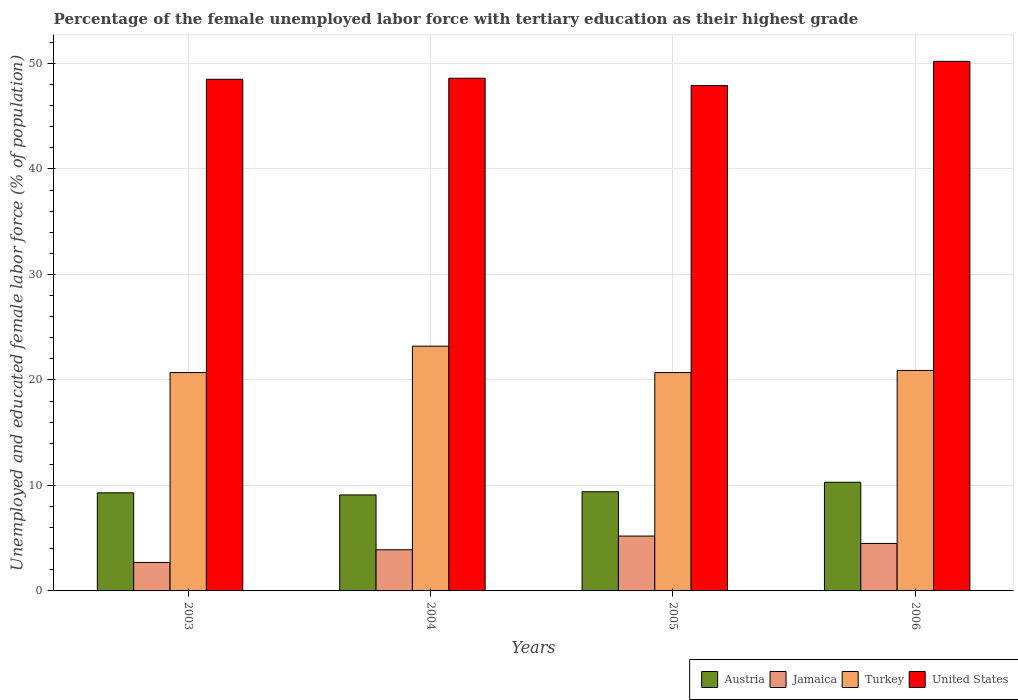How many different coloured bars are there?
Provide a succinct answer. 4. Are the number of bars on each tick of the X-axis equal?
Offer a terse response. Yes. How many bars are there on the 2nd tick from the right?
Make the answer very short. 4. What is the percentage of the unemployed female labor force with tertiary education in Turkey in 2006?
Your response must be concise. 20.9. Across all years, what is the maximum percentage of the unemployed female labor force with tertiary education in United States?
Offer a very short reply. 50.2. Across all years, what is the minimum percentage of the unemployed female labor force with tertiary education in Jamaica?
Provide a succinct answer. 2.7. In which year was the percentage of the unemployed female labor force with tertiary education in Jamaica maximum?
Ensure brevity in your answer.  2005. What is the total percentage of the unemployed female labor force with tertiary education in Austria in the graph?
Your answer should be very brief. 38.1. What is the difference between the percentage of the unemployed female labor force with tertiary education in United States in 2003 and the percentage of the unemployed female labor force with tertiary education in Austria in 2005?
Your answer should be very brief. 39.1. What is the average percentage of the unemployed female labor force with tertiary education in Jamaica per year?
Offer a very short reply. 4.07. In the year 2006, what is the difference between the percentage of the unemployed female labor force with tertiary education in Turkey and percentage of the unemployed female labor force with tertiary education in United States?
Offer a terse response. -29.3. In how many years, is the percentage of the unemployed female labor force with tertiary education in Turkey greater than 28 %?
Provide a succinct answer. 0. What is the ratio of the percentage of the unemployed female labor force with tertiary education in United States in 2003 to that in 2005?
Provide a succinct answer. 1.01. Is the difference between the percentage of the unemployed female labor force with tertiary education in Turkey in 2005 and 2006 greater than the difference between the percentage of the unemployed female labor force with tertiary education in United States in 2005 and 2006?
Offer a very short reply. Yes. What is the difference between the highest and the second highest percentage of the unemployed female labor force with tertiary education in Jamaica?
Keep it short and to the point. 0.7. What is the difference between the highest and the lowest percentage of the unemployed female labor force with tertiary education in Jamaica?
Make the answer very short. 2.5. Is the sum of the percentage of the unemployed female labor force with tertiary education in Austria in 2004 and 2006 greater than the maximum percentage of the unemployed female labor force with tertiary education in Jamaica across all years?
Provide a succinct answer. Yes. Is it the case that in every year, the sum of the percentage of the unemployed female labor force with tertiary education in Jamaica and percentage of the unemployed female labor force with tertiary education in Austria is greater than the sum of percentage of the unemployed female labor force with tertiary education in United States and percentage of the unemployed female labor force with tertiary education in Turkey?
Your answer should be compact. No. What does the 2nd bar from the left in 2003 represents?
Make the answer very short. Jamaica. What does the 1st bar from the right in 2003 represents?
Your answer should be compact. United States. Is it the case that in every year, the sum of the percentage of the unemployed female labor force with tertiary education in United States and percentage of the unemployed female labor force with tertiary education in Turkey is greater than the percentage of the unemployed female labor force with tertiary education in Jamaica?
Offer a terse response. Yes. How many bars are there?
Make the answer very short. 16. Are all the bars in the graph horizontal?
Offer a very short reply. No. Are the values on the major ticks of Y-axis written in scientific E-notation?
Keep it short and to the point. No. Does the graph contain any zero values?
Ensure brevity in your answer.  No. Does the graph contain grids?
Keep it short and to the point. Yes. Where does the legend appear in the graph?
Provide a short and direct response. Bottom right. How are the legend labels stacked?
Offer a terse response. Horizontal. What is the title of the graph?
Give a very brief answer. Percentage of the female unemployed labor force with tertiary education as their highest grade. What is the label or title of the X-axis?
Your answer should be very brief. Years. What is the label or title of the Y-axis?
Your answer should be compact. Unemployed and educated female labor force (% of population). What is the Unemployed and educated female labor force (% of population) of Austria in 2003?
Keep it short and to the point. 9.3. What is the Unemployed and educated female labor force (% of population) in Jamaica in 2003?
Give a very brief answer. 2.7. What is the Unemployed and educated female labor force (% of population) of Turkey in 2003?
Provide a succinct answer. 20.7. What is the Unemployed and educated female labor force (% of population) of United States in 2003?
Your response must be concise. 48.5. What is the Unemployed and educated female labor force (% of population) of Austria in 2004?
Give a very brief answer. 9.1. What is the Unemployed and educated female labor force (% of population) in Jamaica in 2004?
Ensure brevity in your answer.  3.9. What is the Unemployed and educated female labor force (% of population) in Turkey in 2004?
Provide a short and direct response. 23.2. What is the Unemployed and educated female labor force (% of population) of United States in 2004?
Provide a short and direct response. 48.6. What is the Unemployed and educated female labor force (% of population) of Austria in 2005?
Keep it short and to the point. 9.4. What is the Unemployed and educated female labor force (% of population) of Jamaica in 2005?
Provide a succinct answer. 5.2. What is the Unemployed and educated female labor force (% of population) in Turkey in 2005?
Keep it short and to the point. 20.7. What is the Unemployed and educated female labor force (% of population) in United States in 2005?
Your answer should be very brief. 47.9. What is the Unemployed and educated female labor force (% of population) in Austria in 2006?
Provide a succinct answer. 10.3. What is the Unemployed and educated female labor force (% of population) in Turkey in 2006?
Make the answer very short. 20.9. What is the Unemployed and educated female labor force (% of population) of United States in 2006?
Your response must be concise. 50.2. Across all years, what is the maximum Unemployed and educated female labor force (% of population) in Austria?
Offer a very short reply. 10.3. Across all years, what is the maximum Unemployed and educated female labor force (% of population) in Jamaica?
Offer a terse response. 5.2. Across all years, what is the maximum Unemployed and educated female labor force (% of population) of Turkey?
Your answer should be compact. 23.2. Across all years, what is the maximum Unemployed and educated female labor force (% of population) of United States?
Provide a succinct answer. 50.2. Across all years, what is the minimum Unemployed and educated female labor force (% of population) of Austria?
Make the answer very short. 9.1. Across all years, what is the minimum Unemployed and educated female labor force (% of population) of Jamaica?
Give a very brief answer. 2.7. Across all years, what is the minimum Unemployed and educated female labor force (% of population) in Turkey?
Ensure brevity in your answer.  20.7. Across all years, what is the minimum Unemployed and educated female labor force (% of population) in United States?
Your response must be concise. 47.9. What is the total Unemployed and educated female labor force (% of population) in Austria in the graph?
Provide a succinct answer. 38.1. What is the total Unemployed and educated female labor force (% of population) of Jamaica in the graph?
Ensure brevity in your answer.  16.3. What is the total Unemployed and educated female labor force (% of population) in Turkey in the graph?
Keep it short and to the point. 85.5. What is the total Unemployed and educated female labor force (% of population) in United States in the graph?
Provide a succinct answer. 195.2. What is the difference between the Unemployed and educated female labor force (% of population) of Austria in 2003 and that in 2005?
Offer a terse response. -0.1. What is the difference between the Unemployed and educated female labor force (% of population) in Jamaica in 2003 and that in 2005?
Provide a succinct answer. -2.5. What is the difference between the Unemployed and educated female labor force (% of population) in United States in 2003 and that in 2005?
Your response must be concise. 0.6. What is the difference between the Unemployed and educated female labor force (% of population) in Austria in 2004 and that in 2005?
Give a very brief answer. -0.3. What is the difference between the Unemployed and educated female labor force (% of population) of Turkey in 2004 and that in 2005?
Offer a very short reply. 2.5. What is the difference between the Unemployed and educated female labor force (% of population) of United States in 2004 and that in 2005?
Offer a very short reply. 0.7. What is the difference between the Unemployed and educated female labor force (% of population) of Turkey in 2004 and that in 2006?
Your answer should be very brief. 2.3. What is the difference between the Unemployed and educated female labor force (% of population) of United States in 2005 and that in 2006?
Provide a succinct answer. -2.3. What is the difference between the Unemployed and educated female labor force (% of population) in Austria in 2003 and the Unemployed and educated female labor force (% of population) in United States in 2004?
Offer a terse response. -39.3. What is the difference between the Unemployed and educated female labor force (% of population) of Jamaica in 2003 and the Unemployed and educated female labor force (% of population) of Turkey in 2004?
Your answer should be compact. -20.5. What is the difference between the Unemployed and educated female labor force (% of population) of Jamaica in 2003 and the Unemployed and educated female labor force (% of population) of United States in 2004?
Give a very brief answer. -45.9. What is the difference between the Unemployed and educated female labor force (% of population) of Turkey in 2003 and the Unemployed and educated female labor force (% of population) of United States in 2004?
Provide a succinct answer. -27.9. What is the difference between the Unemployed and educated female labor force (% of population) of Austria in 2003 and the Unemployed and educated female labor force (% of population) of Jamaica in 2005?
Give a very brief answer. 4.1. What is the difference between the Unemployed and educated female labor force (% of population) in Austria in 2003 and the Unemployed and educated female labor force (% of population) in United States in 2005?
Make the answer very short. -38.6. What is the difference between the Unemployed and educated female labor force (% of population) in Jamaica in 2003 and the Unemployed and educated female labor force (% of population) in United States in 2005?
Provide a succinct answer. -45.2. What is the difference between the Unemployed and educated female labor force (% of population) in Turkey in 2003 and the Unemployed and educated female labor force (% of population) in United States in 2005?
Keep it short and to the point. -27.2. What is the difference between the Unemployed and educated female labor force (% of population) in Austria in 2003 and the Unemployed and educated female labor force (% of population) in Turkey in 2006?
Offer a terse response. -11.6. What is the difference between the Unemployed and educated female labor force (% of population) in Austria in 2003 and the Unemployed and educated female labor force (% of population) in United States in 2006?
Keep it short and to the point. -40.9. What is the difference between the Unemployed and educated female labor force (% of population) in Jamaica in 2003 and the Unemployed and educated female labor force (% of population) in Turkey in 2006?
Give a very brief answer. -18.2. What is the difference between the Unemployed and educated female labor force (% of population) of Jamaica in 2003 and the Unemployed and educated female labor force (% of population) of United States in 2006?
Your answer should be compact. -47.5. What is the difference between the Unemployed and educated female labor force (% of population) of Turkey in 2003 and the Unemployed and educated female labor force (% of population) of United States in 2006?
Your answer should be very brief. -29.5. What is the difference between the Unemployed and educated female labor force (% of population) of Austria in 2004 and the Unemployed and educated female labor force (% of population) of Jamaica in 2005?
Your answer should be very brief. 3.9. What is the difference between the Unemployed and educated female labor force (% of population) of Austria in 2004 and the Unemployed and educated female labor force (% of population) of United States in 2005?
Your answer should be very brief. -38.8. What is the difference between the Unemployed and educated female labor force (% of population) of Jamaica in 2004 and the Unemployed and educated female labor force (% of population) of Turkey in 2005?
Provide a short and direct response. -16.8. What is the difference between the Unemployed and educated female labor force (% of population) of Jamaica in 2004 and the Unemployed and educated female labor force (% of population) of United States in 2005?
Provide a short and direct response. -44. What is the difference between the Unemployed and educated female labor force (% of population) in Turkey in 2004 and the Unemployed and educated female labor force (% of population) in United States in 2005?
Give a very brief answer. -24.7. What is the difference between the Unemployed and educated female labor force (% of population) of Austria in 2004 and the Unemployed and educated female labor force (% of population) of Jamaica in 2006?
Provide a succinct answer. 4.6. What is the difference between the Unemployed and educated female labor force (% of population) of Austria in 2004 and the Unemployed and educated female labor force (% of population) of United States in 2006?
Offer a terse response. -41.1. What is the difference between the Unemployed and educated female labor force (% of population) of Jamaica in 2004 and the Unemployed and educated female labor force (% of population) of United States in 2006?
Keep it short and to the point. -46.3. What is the difference between the Unemployed and educated female labor force (% of population) in Turkey in 2004 and the Unemployed and educated female labor force (% of population) in United States in 2006?
Keep it short and to the point. -27. What is the difference between the Unemployed and educated female labor force (% of population) of Austria in 2005 and the Unemployed and educated female labor force (% of population) of Turkey in 2006?
Your response must be concise. -11.5. What is the difference between the Unemployed and educated female labor force (% of population) in Austria in 2005 and the Unemployed and educated female labor force (% of population) in United States in 2006?
Provide a short and direct response. -40.8. What is the difference between the Unemployed and educated female labor force (% of population) in Jamaica in 2005 and the Unemployed and educated female labor force (% of population) in Turkey in 2006?
Ensure brevity in your answer.  -15.7. What is the difference between the Unemployed and educated female labor force (% of population) of Jamaica in 2005 and the Unemployed and educated female labor force (% of population) of United States in 2006?
Your answer should be compact. -45. What is the difference between the Unemployed and educated female labor force (% of population) in Turkey in 2005 and the Unemployed and educated female labor force (% of population) in United States in 2006?
Give a very brief answer. -29.5. What is the average Unemployed and educated female labor force (% of population) in Austria per year?
Give a very brief answer. 9.53. What is the average Unemployed and educated female labor force (% of population) in Jamaica per year?
Provide a succinct answer. 4.08. What is the average Unemployed and educated female labor force (% of population) in Turkey per year?
Ensure brevity in your answer.  21.38. What is the average Unemployed and educated female labor force (% of population) of United States per year?
Your answer should be very brief. 48.8. In the year 2003, what is the difference between the Unemployed and educated female labor force (% of population) of Austria and Unemployed and educated female labor force (% of population) of Jamaica?
Offer a very short reply. 6.6. In the year 2003, what is the difference between the Unemployed and educated female labor force (% of population) of Austria and Unemployed and educated female labor force (% of population) of Turkey?
Ensure brevity in your answer.  -11.4. In the year 2003, what is the difference between the Unemployed and educated female labor force (% of population) in Austria and Unemployed and educated female labor force (% of population) in United States?
Ensure brevity in your answer.  -39.2. In the year 2003, what is the difference between the Unemployed and educated female labor force (% of population) of Jamaica and Unemployed and educated female labor force (% of population) of United States?
Offer a terse response. -45.8. In the year 2003, what is the difference between the Unemployed and educated female labor force (% of population) of Turkey and Unemployed and educated female labor force (% of population) of United States?
Your response must be concise. -27.8. In the year 2004, what is the difference between the Unemployed and educated female labor force (% of population) of Austria and Unemployed and educated female labor force (% of population) of Turkey?
Provide a succinct answer. -14.1. In the year 2004, what is the difference between the Unemployed and educated female labor force (% of population) in Austria and Unemployed and educated female labor force (% of population) in United States?
Provide a short and direct response. -39.5. In the year 2004, what is the difference between the Unemployed and educated female labor force (% of population) of Jamaica and Unemployed and educated female labor force (% of population) of Turkey?
Provide a short and direct response. -19.3. In the year 2004, what is the difference between the Unemployed and educated female labor force (% of population) of Jamaica and Unemployed and educated female labor force (% of population) of United States?
Provide a succinct answer. -44.7. In the year 2004, what is the difference between the Unemployed and educated female labor force (% of population) in Turkey and Unemployed and educated female labor force (% of population) in United States?
Your answer should be compact. -25.4. In the year 2005, what is the difference between the Unemployed and educated female labor force (% of population) in Austria and Unemployed and educated female labor force (% of population) in Jamaica?
Keep it short and to the point. 4.2. In the year 2005, what is the difference between the Unemployed and educated female labor force (% of population) of Austria and Unemployed and educated female labor force (% of population) of Turkey?
Offer a terse response. -11.3. In the year 2005, what is the difference between the Unemployed and educated female labor force (% of population) of Austria and Unemployed and educated female labor force (% of population) of United States?
Provide a short and direct response. -38.5. In the year 2005, what is the difference between the Unemployed and educated female labor force (% of population) of Jamaica and Unemployed and educated female labor force (% of population) of Turkey?
Give a very brief answer. -15.5. In the year 2005, what is the difference between the Unemployed and educated female labor force (% of population) of Jamaica and Unemployed and educated female labor force (% of population) of United States?
Provide a succinct answer. -42.7. In the year 2005, what is the difference between the Unemployed and educated female labor force (% of population) of Turkey and Unemployed and educated female labor force (% of population) of United States?
Provide a succinct answer. -27.2. In the year 2006, what is the difference between the Unemployed and educated female labor force (% of population) of Austria and Unemployed and educated female labor force (% of population) of United States?
Offer a very short reply. -39.9. In the year 2006, what is the difference between the Unemployed and educated female labor force (% of population) of Jamaica and Unemployed and educated female labor force (% of population) of Turkey?
Your answer should be very brief. -16.4. In the year 2006, what is the difference between the Unemployed and educated female labor force (% of population) of Jamaica and Unemployed and educated female labor force (% of population) of United States?
Your response must be concise. -45.7. In the year 2006, what is the difference between the Unemployed and educated female labor force (% of population) of Turkey and Unemployed and educated female labor force (% of population) of United States?
Offer a very short reply. -29.3. What is the ratio of the Unemployed and educated female labor force (% of population) of Austria in 2003 to that in 2004?
Your answer should be very brief. 1.02. What is the ratio of the Unemployed and educated female labor force (% of population) in Jamaica in 2003 to that in 2004?
Give a very brief answer. 0.69. What is the ratio of the Unemployed and educated female labor force (% of population) of Turkey in 2003 to that in 2004?
Provide a short and direct response. 0.89. What is the ratio of the Unemployed and educated female labor force (% of population) of United States in 2003 to that in 2004?
Offer a very short reply. 1. What is the ratio of the Unemployed and educated female labor force (% of population) of Austria in 2003 to that in 2005?
Your answer should be very brief. 0.99. What is the ratio of the Unemployed and educated female labor force (% of population) in Jamaica in 2003 to that in 2005?
Ensure brevity in your answer.  0.52. What is the ratio of the Unemployed and educated female labor force (% of population) of Turkey in 2003 to that in 2005?
Provide a succinct answer. 1. What is the ratio of the Unemployed and educated female labor force (% of population) in United States in 2003 to that in 2005?
Make the answer very short. 1.01. What is the ratio of the Unemployed and educated female labor force (% of population) of Austria in 2003 to that in 2006?
Make the answer very short. 0.9. What is the ratio of the Unemployed and educated female labor force (% of population) in United States in 2003 to that in 2006?
Make the answer very short. 0.97. What is the ratio of the Unemployed and educated female labor force (% of population) of Austria in 2004 to that in 2005?
Offer a very short reply. 0.97. What is the ratio of the Unemployed and educated female labor force (% of population) of Turkey in 2004 to that in 2005?
Keep it short and to the point. 1.12. What is the ratio of the Unemployed and educated female labor force (% of population) of United States in 2004 to that in 2005?
Your response must be concise. 1.01. What is the ratio of the Unemployed and educated female labor force (% of population) of Austria in 2004 to that in 2006?
Provide a short and direct response. 0.88. What is the ratio of the Unemployed and educated female labor force (% of population) of Jamaica in 2004 to that in 2006?
Your response must be concise. 0.87. What is the ratio of the Unemployed and educated female labor force (% of population) in Turkey in 2004 to that in 2006?
Keep it short and to the point. 1.11. What is the ratio of the Unemployed and educated female labor force (% of population) in United States in 2004 to that in 2006?
Your answer should be very brief. 0.97. What is the ratio of the Unemployed and educated female labor force (% of population) in Austria in 2005 to that in 2006?
Give a very brief answer. 0.91. What is the ratio of the Unemployed and educated female labor force (% of population) of Jamaica in 2005 to that in 2006?
Provide a short and direct response. 1.16. What is the ratio of the Unemployed and educated female labor force (% of population) of United States in 2005 to that in 2006?
Provide a succinct answer. 0.95. What is the difference between the highest and the second highest Unemployed and educated female labor force (% of population) in United States?
Provide a short and direct response. 1.6. What is the difference between the highest and the lowest Unemployed and educated female labor force (% of population) in Jamaica?
Give a very brief answer. 2.5. What is the difference between the highest and the lowest Unemployed and educated female labor force (% of population) in Turkey?
Keep it short and to the point. 2.5. 